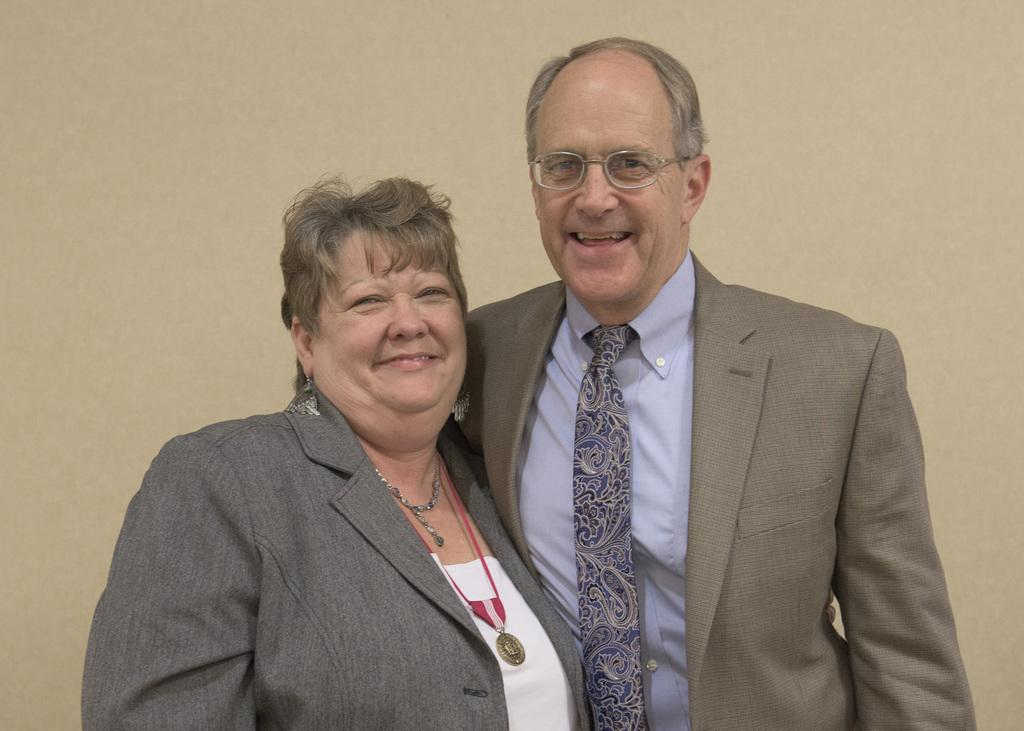How many people are present in the image? There are two people, a man and a woman, present in the image. Where are the man and woman located in the image? The man and woman are in the center of the image. What can be seen in the background of the image? There is a wall in the background of the image. What is the man writing on the wall in the image? There is no indication in the image that the man is writing on the wall, as there is no visible writing or any tools for writing present. 